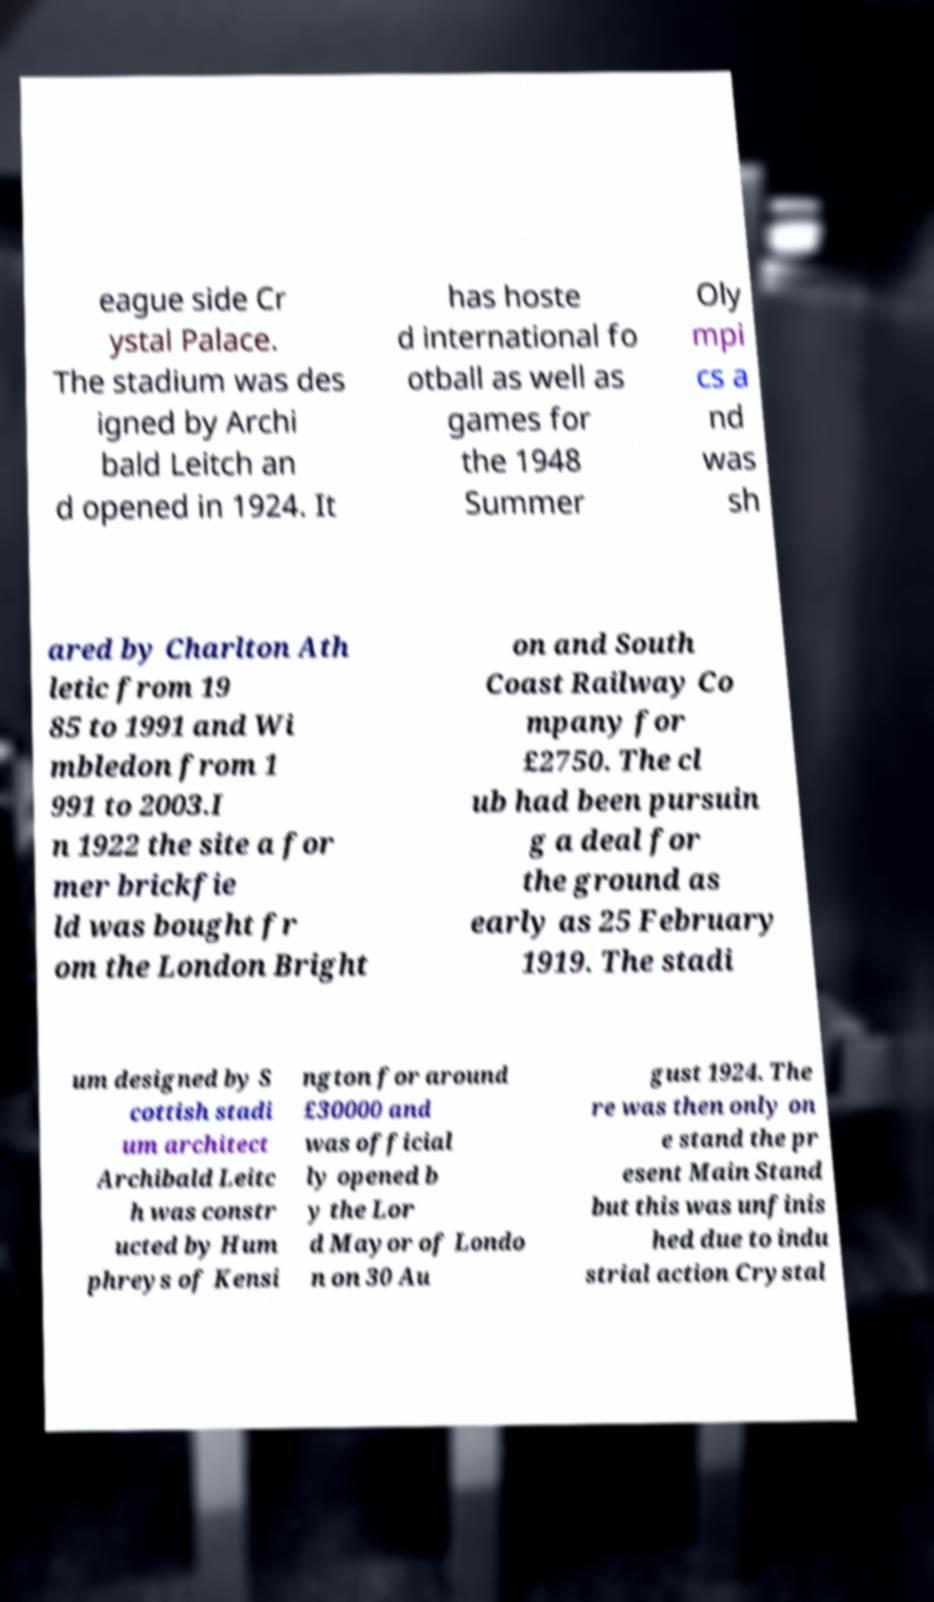There's text embedded in this image that I need extracted. Can you transcribe it verbatim? eague side Cr ystal Palace. The stadium was des igned by Archi bald Leitch an d opened in 1924. It has hoste d international fo otball as well as games for the 1948 Summer Oly mpi cs a nd was sh ared by Charlton Ath letic from 19 85 to 1991 and Wi mbledon from 1 991 to 2003.I n 1922 the site a for mer brickfie ld was bought fr om the London Bright on and South Coast Railway Co mpany for £2750. The cl ub had been pursuin g a deal for the ground as early as 25 February 1919. The stadi um designed by S cottish stadi um architect Archibald Leitc h was constr ucted by Hum phreys of Kensi ngton for around £30000 and was official ly opened b y the Lor d Mayor of Londo n on 30 Au gust 1924. The re was then only on e stand the pr esent Main Stand but this was unfinis hed due to indu strial action Crystal 